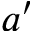Convert formula to latex. <formula><loc_0><loc_0><loc_500><loc_500>a ^ { \prime }</formula> 